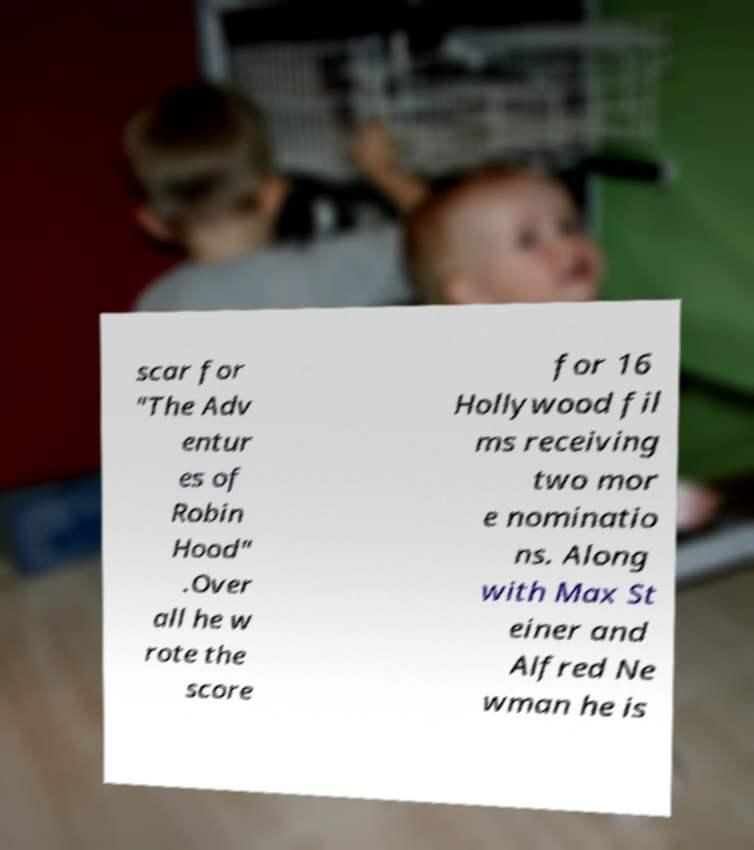For documentation purposes, I need the text within this image transcribed. Could you provide that? scar for "The Adv entur es of Robin Hood" .Over all he w rote the score for 16 Hollywood fil ms receiving two mor e nominatio ns. Along with Max St einer and Alfred Ne wman he is 